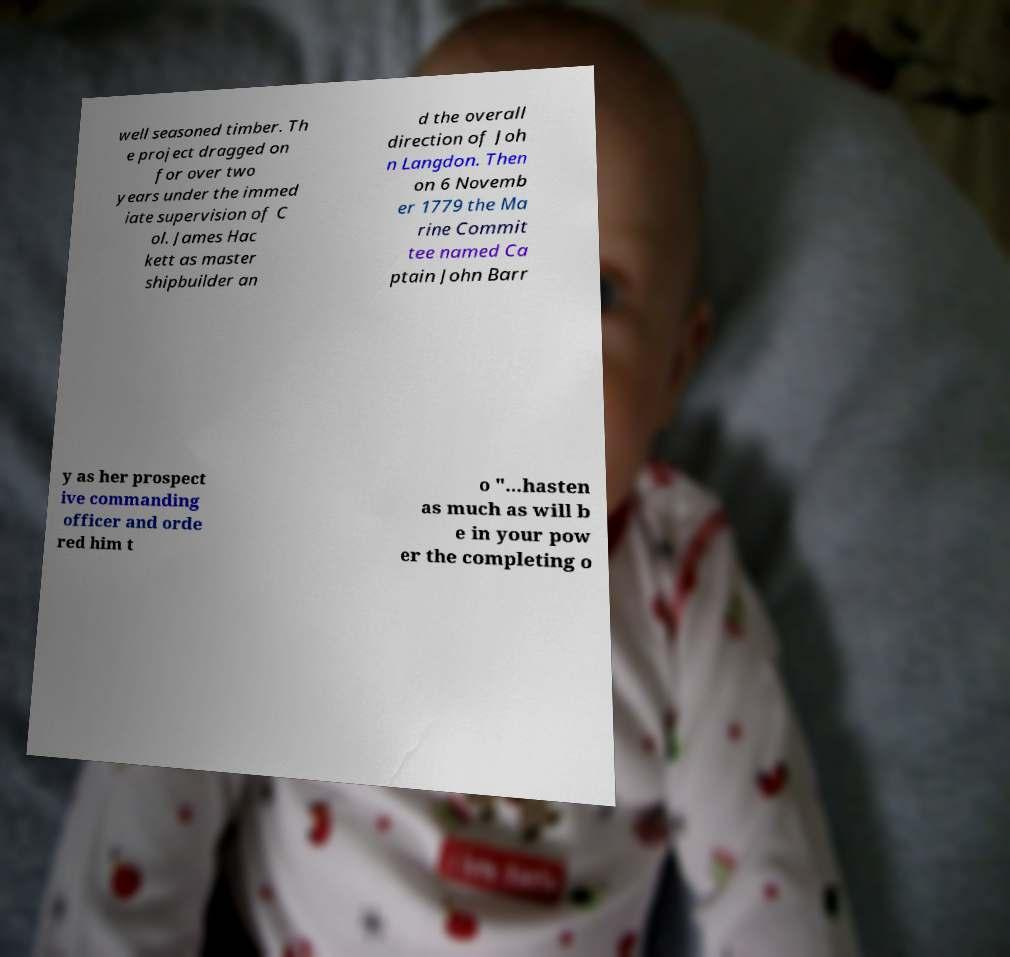Can you read and provide the text displayed in the image?This photo seems to have some interesting text. Can you extract and type it out for me? well seasoned timber. Th e project dragged on for over two years under the immed iate supervision of C ol. James Hac kett as master shipbuilder an d the overall direction of Joh n Langdon. Then on 6 Novemb er 1779 the Ma rine Commit tee named Ca ptain John Barr y as her prospect ive commanding officer and orde red him t o "...hasten as much as will b e in your pow er the completing o 